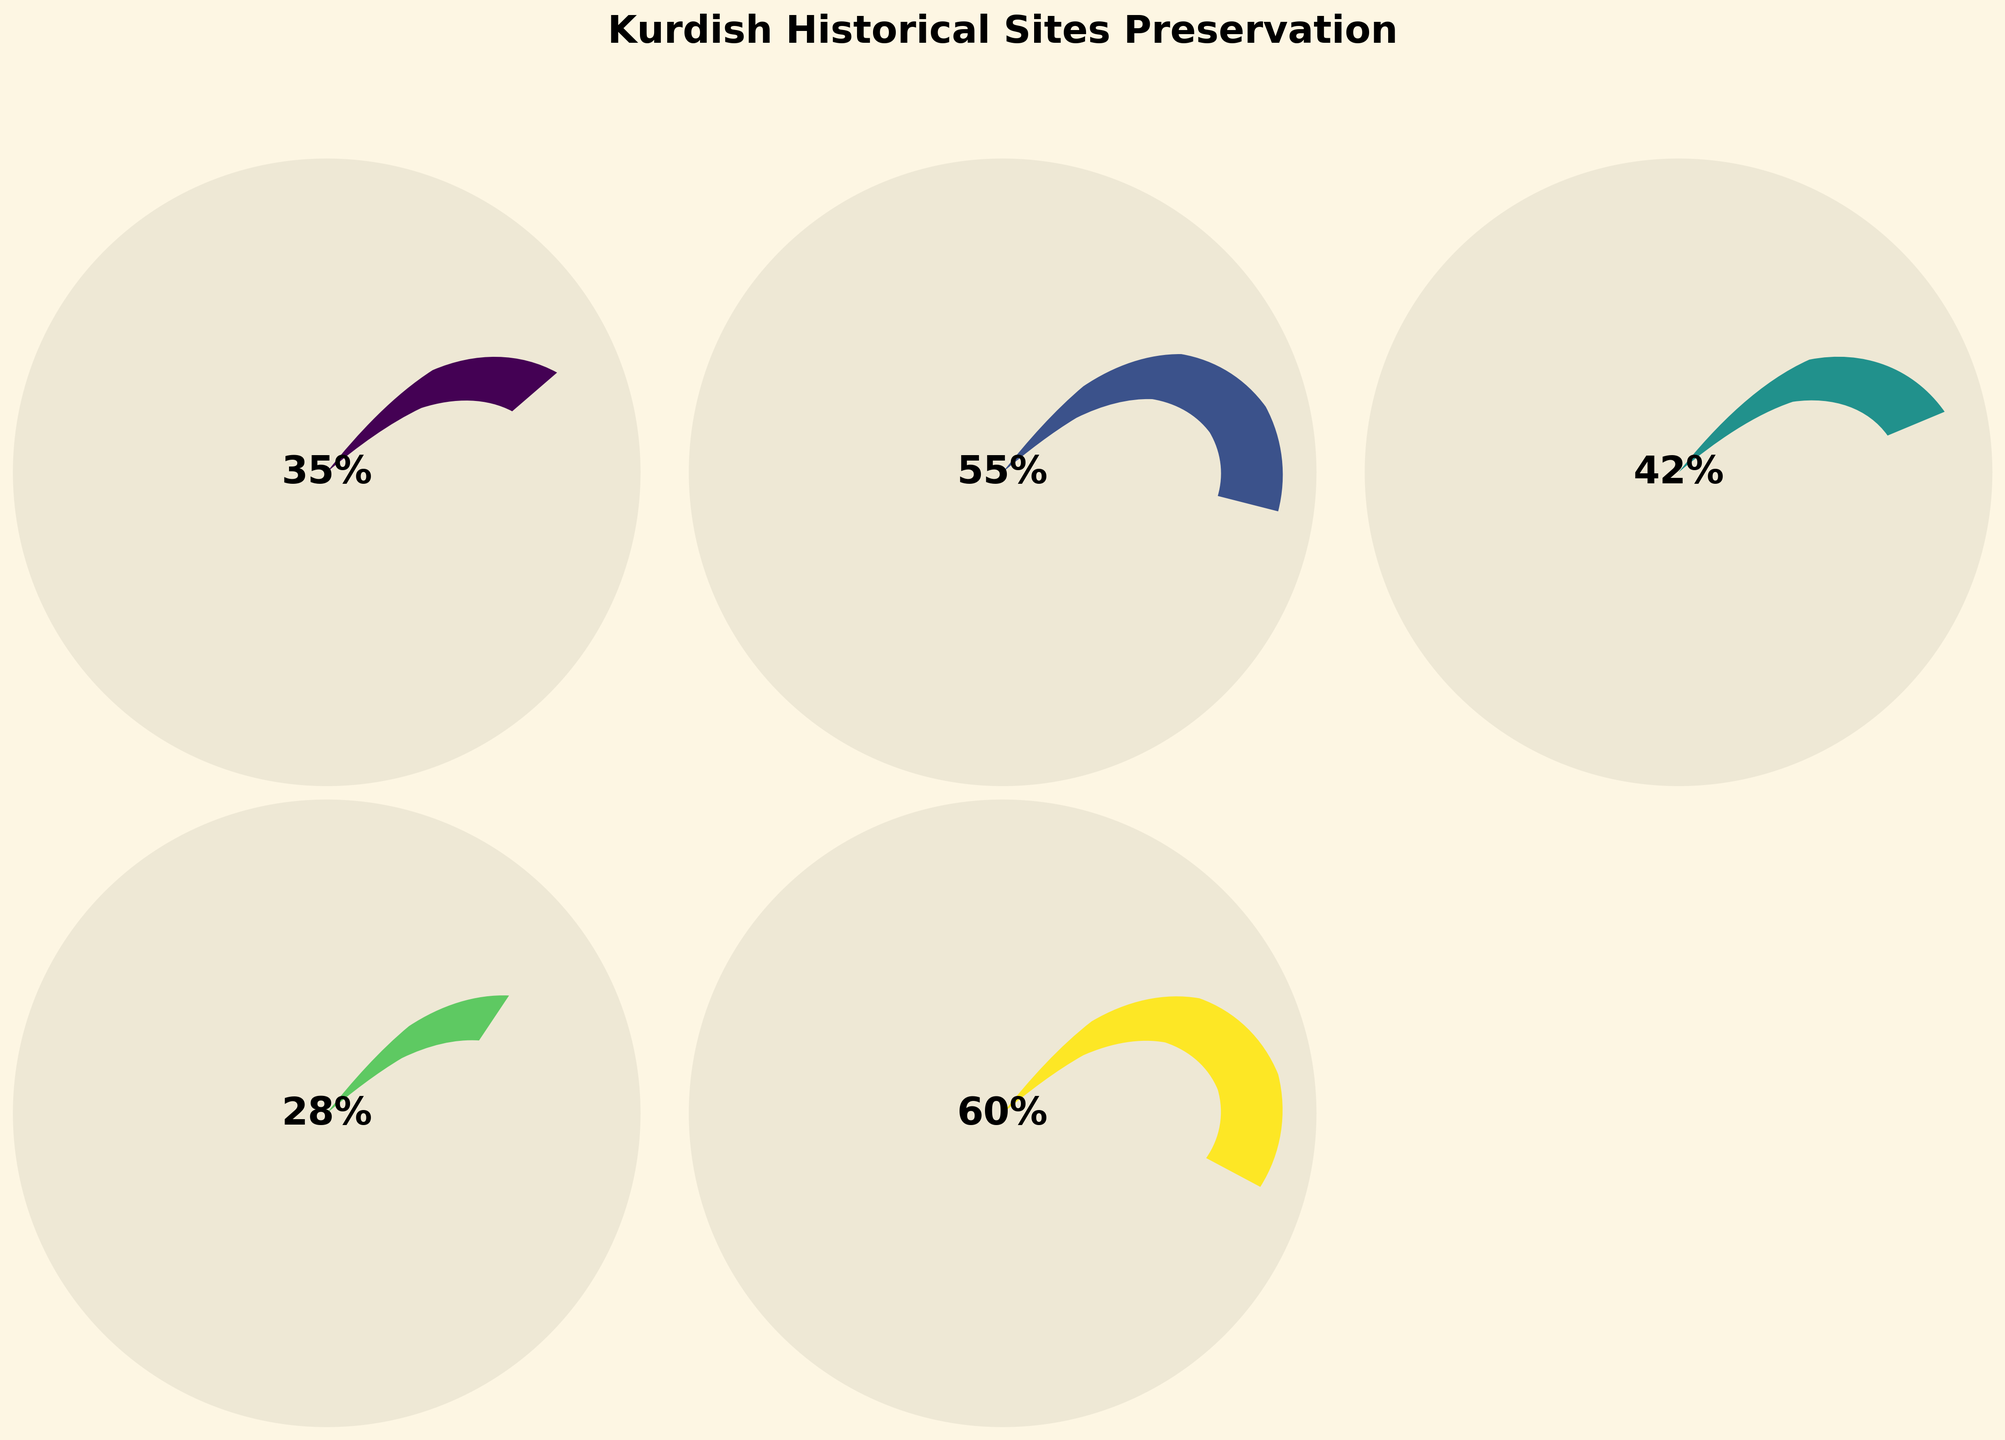What's the title of the figure? The title is usually located at the top of a figure and provides a summary of what the figure represents. Here, it reads "Kurdish Historical Sites Preservation".
Answer: Kurdish Historical Sites Preservation Which country has the highest preservation percentage? By comparing the gauge values visually, Armenia has the highest value because its gauge is the most filled, corresponding to 60%.
Answer: Armenia Which country has the lowest preservation percentage? By examining the gauges, Syria has the lowest gauge fill, representing the least preservation percentage at 28%.
Answer: Syria Which two countries have a preservation percentage above 50%? By looking at the gauges that surpass the 50% mark, both Iran and Armenia meet this criterion with 55% and 60%, respectively.
Answer: Iran, Armenia What is the average preservation percentage of the Kurdish historical sites among these countries? Sum the percentages (35 + 55 + 42 + 28 + 60) to get 220, then divide by the number of countries (5) to get the average. The calculation is 220/5 = 44.
Answer: 44 Is the preservation percentage in Turkey higher or lower than in Iraq? By comparing the positions of the gauges, Turkey has a preservation percentage of 35%, whereas Iraq has a percentage of 42%, making Turkey's lower.
Answer: Lower What is the difference in preservation percentage between Iran and Syria? Subtract Syria's percentage (28%) from Iran's percentage (55%). So, 55 - 28 = 27.
Answer: 27 Which country has a preservation percentage closest to the overall average? The average calculated before is 44. Iraq's percentage is 42, which is the closest to 44 compared to other countries.
Answer: Iraq How many countries have a preservation percentage below 40%? Evaluate each gauge: Turkey (35%), Syria (28%), both are below 40%. Hence, 2 countries meet this criterion.
Answer: 2 What is the median preservation percentage of the Kurdish historical sites among these countries? Arrange percentages in ascending order (28, 35, 42, 55, 60). Since 42% is the middle value in this ordered list, it's the median.
Answer: 42 